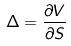<formula> <loc_0><loc_0><loc_500><loc_500>\Delta = \frac { \partial V } { \partial S }</formula> 